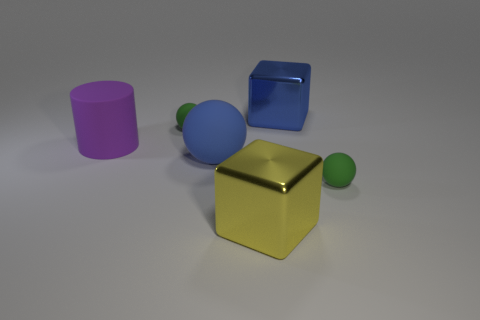Is the material of the big yellow object the same as the large blue sphere that is right of the purple cylinder?
Ensure brevity in your answer.  No. What number of big objects are either green rubber spheres or brown shiny spheres?
Make the answer very short. 0. What is the material of the big thing that is the same color as the large rubber ball?
Provide a succinct answer. Metal. Is the number of small green matte objects less than the number of big blue blocks?
Keep it short and to the point. No. There is a metallic block right of the big yellow thing; does it have the same size as the green sphere that is behind the cylinder?
Make the answer very short. No. How many blue objects are big cylinders or large spheres?
Your response must be concise. 1. Are there more blue matte things than large metallic cubes?
Offer a very short reply. No. What number of objects are shiny blocks or big rubber objects on the right side of the large purple rubber cylinder?
Provide a succinct answer. 3. What number of other things are the same shape as the big purple rubber thing?
Your answer should be very brief. 0. Are there fewer big metal things on the left side of the large purple object than metallic blocks on the right side of the yellow block?
Ensure brevity in your answer.  Yes. 